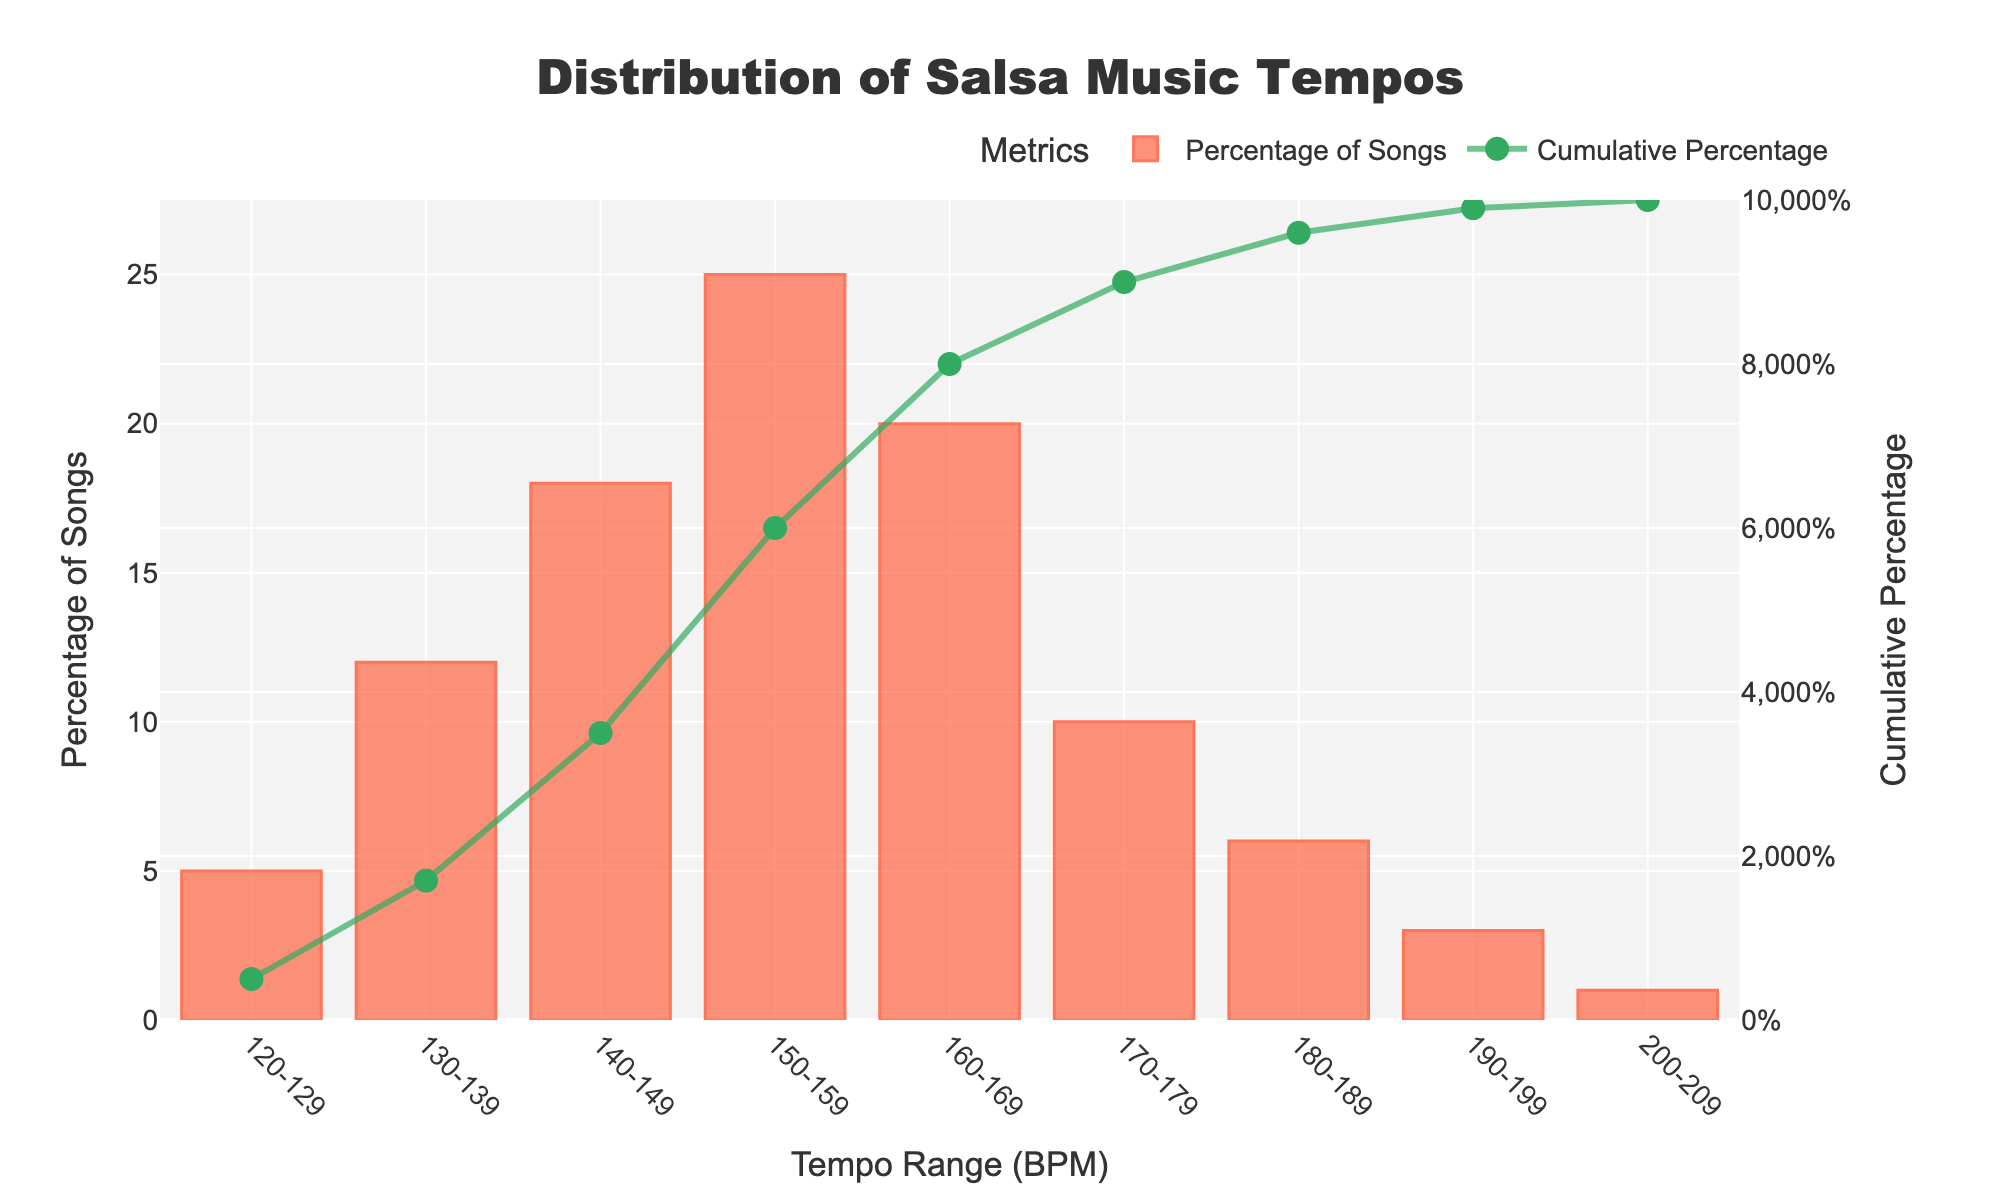What is the most common tempo range for salsa music according to the chart? The highest bar on the chart represents the most common tempo range. The bar for the 150-159 BPM range is the tallest.
Answer: 150-159 BPM How many tempo ranges have a percentage of songs higher than 15%? Identify the bars taller than the 15% mark by visually inspecting the chart. The tempo ranges 140-149 BPM (18%) and 150-159 BPM (25%) are higher than 15%.
Answer: 2 Which tempo range has the lowest percentage of songs? The shortest bar on the chart corresponds to the tempo range with the lowest percentage. The bar for the 200-209 BPM range is the shortest.
Answer: 200-209 BPM What's the combined percentage of songs for the tempo ranges between 160-179 BPM? Sum the percentages for the tempo ranges from 160-169 BPM (20%) and 170-179 BPM (10%). The combined percentage is 20% + 10%.
Answer: 30% How does the cumulative percentage change from the 150-159 BPM range to the 170-179 BPM range? Note the cumulative percentage at the end of the 159 BPM range (1st value higher than 150) and the end of the 179 BPM range. The cumulative percentages are around 55% and 85%, respectively. Thus, a change of 85% - 55%.
Answer: 30% Which tempo ranges have a percentage of songs between 5% and 10%? Identify the bars within the 5% to 10% range by their height. The bars for 120-129 BPM (5%), 170-179 BPM (10%), and 180-189 BPM (6%) fit this range.
Answer: 120-129 BPM, 170-179 BPM, 180-189 BPM What is the percentage difference between the most common and least common tempo ranges? The most common tempo range (150-159 BPM) is 25%. The least common tempo range (200-209 BPM) is 1%. The difference is 25% - 1%.
Answer: 24% How many tempo ranges have a cumulative percentage above 50%? Check the points where the green cumulative line crosses above the 50% mark. The ranges 140-149 BPM and higher achieve this.
Answer: 4 Which tempo range represents a cumulative percentage of approximately 75%? Locate the point where the green cumulative line is closest to 75%. This occurs around the 150-159 BPM range.
Answer: 150-159 BPM Considering only the percentages of songs greater than 10%, what is the average percentage? Tempo ranges over 10% are 130-139 BPM (12%), 140-149 BPM (18%), 150-159 BPM (25%), and 160-169 BPM (20%). The average percentage is (12%+18%+25%+20%)/4.
Answer: 18.75% 